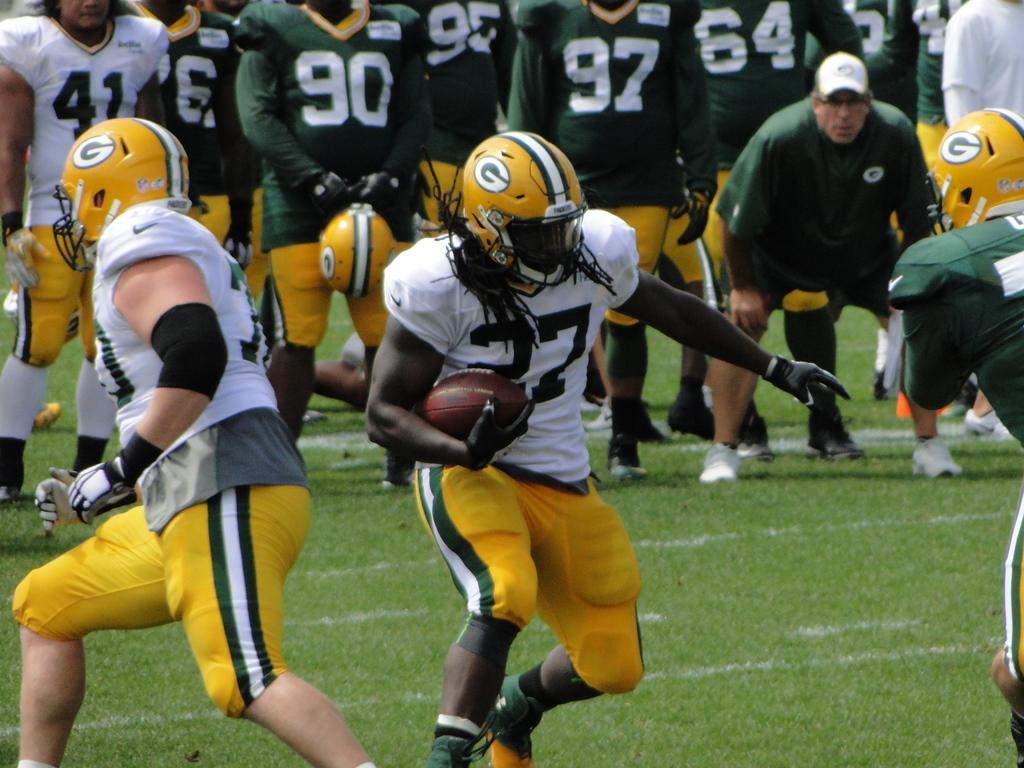Could you give a brief overview of what you see in this image? In this image we can see people playing American football. At the bottom of the image there is grass. 